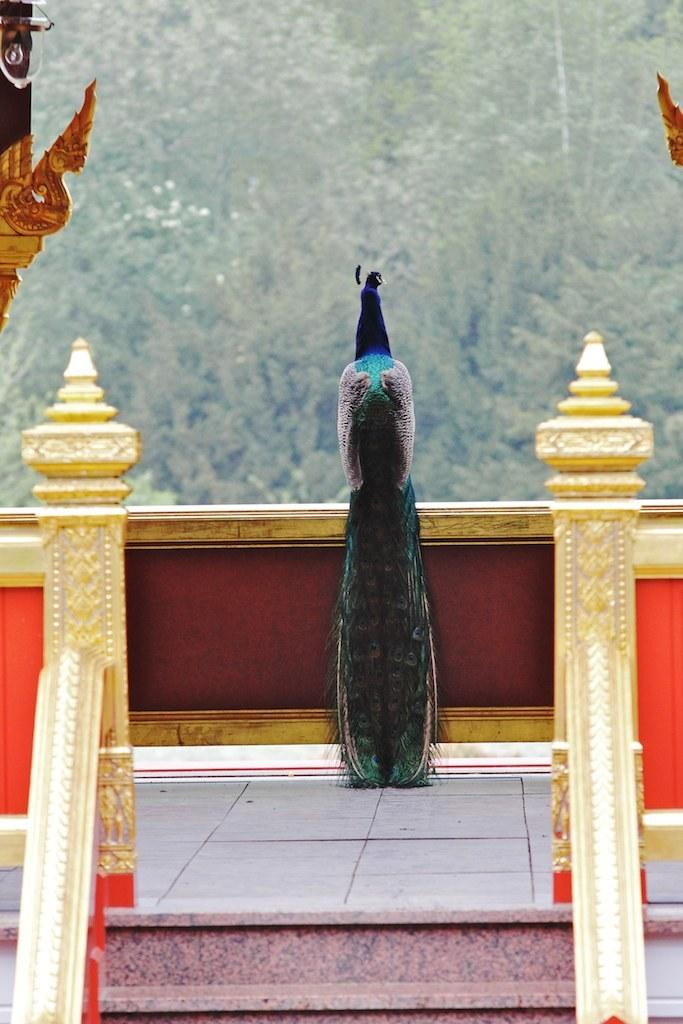What animal is depicted on the wall in the image? There is a peacock on the wall in the center of the image. What architectural feature can be seen at the bottom of the image? There are stairs at the bottom of the image. What type of natural scenery is visible in the background of the image? There are trees visible in the background of the image. What type of knowledge can be gained from the quartz in the image? There is no quartz present in the image, so no knowledge can be gained from it. 